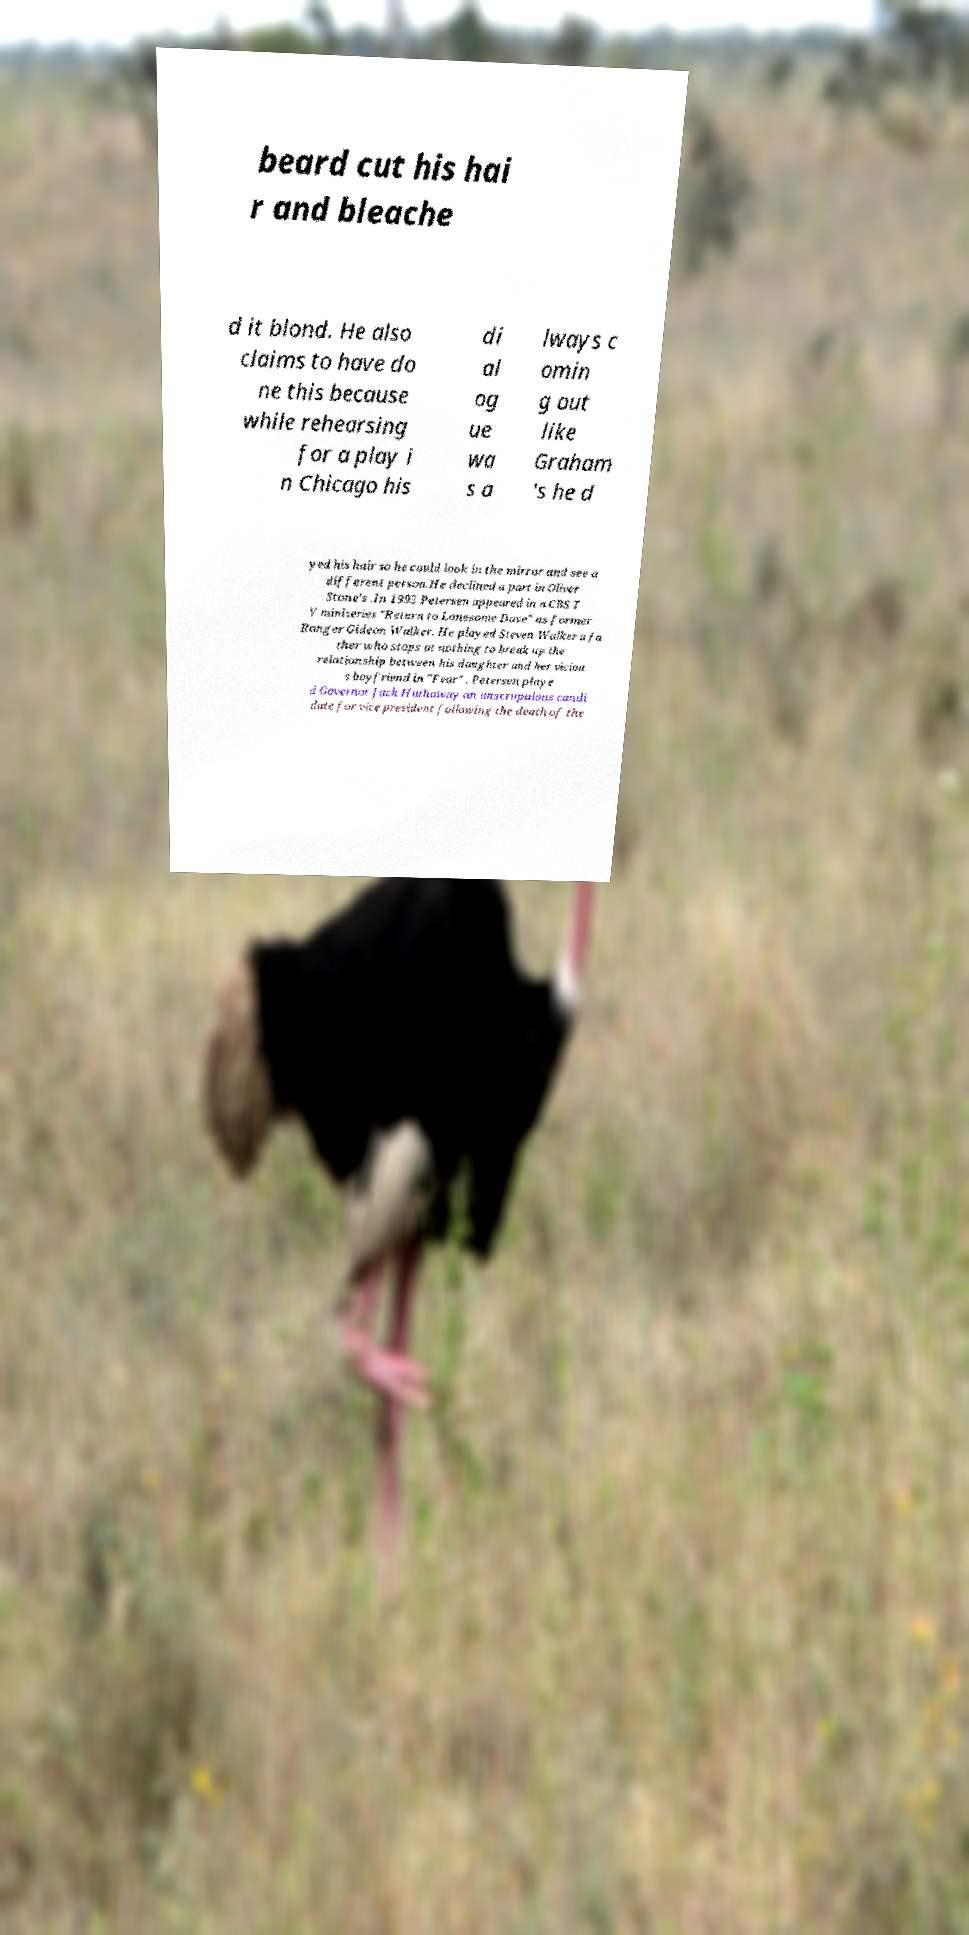Could you assist in decoding the text presented in this image and type it out clearly? beard cut his hai r and bleache d it blond. He also claims to have do ne this because while rehearsing for a play i n Chicago his di al og ue wa s a lways c omin g out like Graham 's he d yed his hair so he could look in the mirror and see a different person.He declined a part in Oliver Stone's .In 1993 Petersen appeared in a CBS T V miniseries "Return to Lonesome Dove" as former Ranger Gideon Walker. He played Steven Walker a fa ther who stops at nothing to break up the relationship between his daughter and her viciou s boyfriend in "Fear" . Petersen playe d Governor Jack Hathaway an unscrupulous candi date for vice president following the death of the 